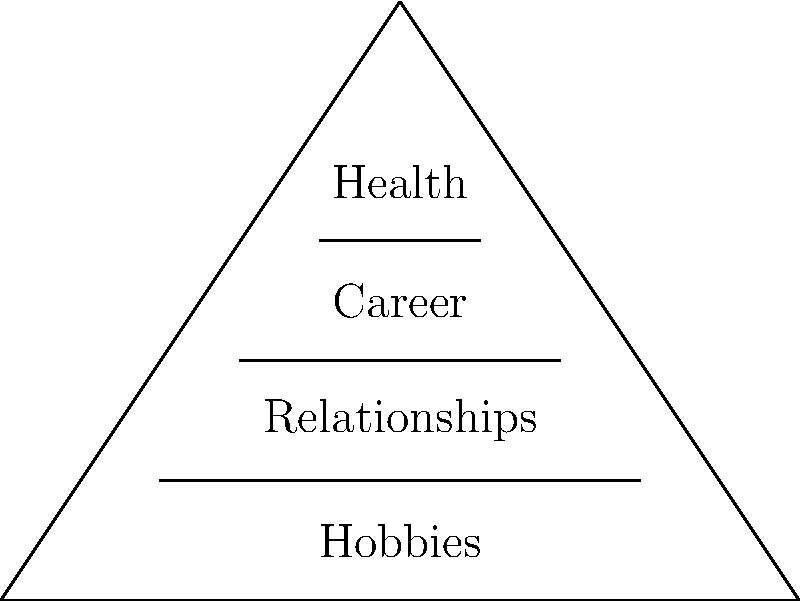Looking at this pyramid diagram of personal goals, which area would you suggest I focus on first to build a strong foundation for my life? What's your reasoning behind this choice? To answer this question, let's analyze the pyramid diagram step-by-step:

1. The pyramid structure: In goal-setting and prioritization, pyramid diagrams often represent a hierarchy of needs or priorities, with the most fundamental elements at the base.

2. Levels of the pyramid:
   - Bottom (largest section): Hobbies
   - Second level: Relationships
   - Third level: Career
   - Top (smallest section): Health

3. Interpretation of the structure:
   - Items at the base are typically considered foundational or essential.
   - As we move up the pyramid, items become more specific or refined.

4. Analysis of each level:
   - Health: While at the top, health is crucial for overall well-being and impacts all other areas.
   - Career: Important for financial stability and personal growth.
   - Relationships: Essential for emotional well-being and support.
   - Hobbies: Contribute to personal fulfillment but are generally considered less critical than the others.

5. Prioritization principle: In most personal development frameworks, health is considered the foundation for everything else. Without good health, it's challenging to excel in career, maintain relationships, or enjoy hobbies.

Given this analysis, the most logical answer would be to focus on health first. Health forms the foundation for all other aspects of life. Good health provides the energy and capacity to pursue career goals, nurture relationships, and enjoy hobbies.
Answer: Health 